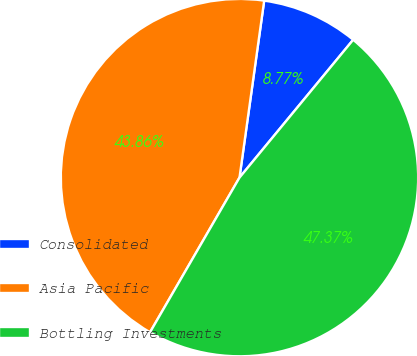Convert chart to OTSL. <chart><loc_0><loc_0><loc_500><loc_500><pie_chart><fcel>Consolidated<fcel>Asia Pacific<fcel>Bottling Investments<nl><fcel>8.77%<fcel>43.86%<fcel>47.37%<nl></chart> 